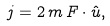Convert formula to latex. <formula><loc_0><loc_0><loc_500><loc_500>j = 2 \, m \, F \cdot \hat { u } ,</formula> 